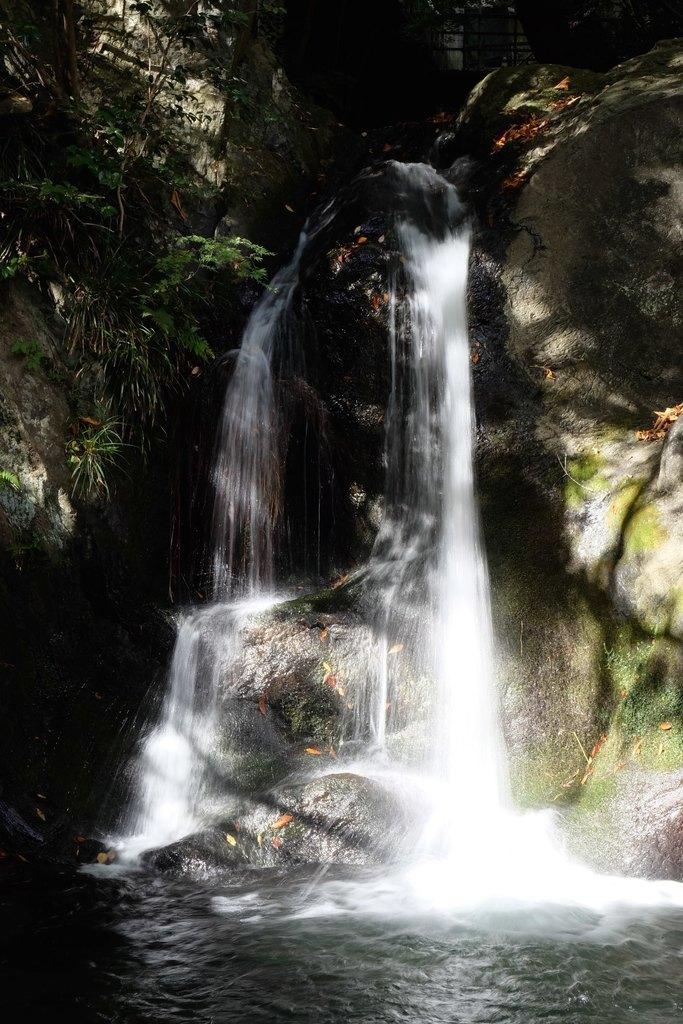What natural feature is the main subject of the image? There is a waterfall in the image. What other elements can be seen in the image besides the waterfall? There are plants in the image. What type of breakfast is being prepared by the brother in the image? There is no brother or breakfast present in the image; it features a waterfall and plants. What type of sponge can be seen in the image? There is no sponge present in the image. 